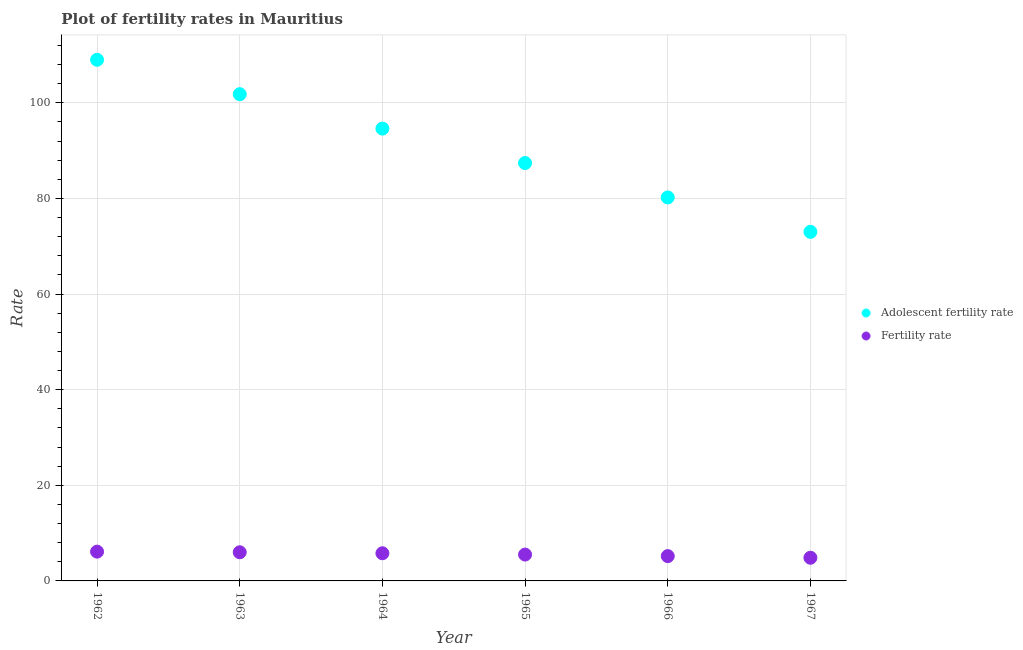How many different coloured dotlines are there?
Give a very brief answer. 2. Is the number of dotlines equal to the number of legend labels?
Keep it short and to the point. Yes. What is the fertility rate in 1964?
Your answer should be very brief. 5.79. Across all years, what is the maximum fertility rate?
Make the answer very short. 6.12. Across all years, what is the minimum adolescent fertility rate?
Keep it short and to the point. 73. In which year was the fertility rate minimum?
Offer a very short reply. 1967. What is the total adolescent fertility rate in the graph?
Give a very brief answer. 545.99. What is the difference between the adolescent fertility rate in 1964 and that in 1966?
Your response must be concise. 14.4. What is the difference between the adolescent fertility rate in 1966 and the fertility rate in 1965?
Your answer should be compact. 74.69. What is the average adolescent fertility rate per year?
Provide a short and direct response. 91. In the year 1966, what is the difference between the fertility rate and adolescent fertility rate?
Make the answer very short. -75.01. What is the ratio of the fertility rate in 1965 to that in 1967?
Provide a succinct answer. 1.14. Is the difference between the adolescent fertility rate in 1966 and 1967 greater than the difference between the fertility rate in 1966 and 1967?
Make the answer very short. Yes. What is the difference between the highest and the second highest fertility rate?
Give a very brief answer. 0.13. What is the difference between the highest and the lowest fertility rate?
Make the answer very short. 1.28. Is the sum of the adolescent fertility rate in 1962 and 1963 greater than the maximum fertility rate across all years?
Offer a very short reply. Yes. How many dotlines are there?
Keep it short and to the point. 2. What is the difference between two consecutive major ticks on the Y-axis?
Ensure brevity in your answer.  20. How many legend labels are there?
Offer a very short reply. 2. What is the title of the graph?
Make the answer very short. Plot of fertility rates in Mauritius. Does "Fraud firms" appear as one of the legend labels in the graph?
Offer a terse response. No. What is the label or title of the X-axis?
Keep it short and to the point. Year. What is the label or title of the Y-axis?
Provide a succinct answer. Rate. What is the Rate of Adolescent fertility rate in 1962?
Your answer should be very brief. 108.99. What is the Rate of Fertility rate in 1962?
Ensure brevity in your answer.  6.12. What is the Rate of Adolescent fertility rate in 1963?
Ensure brevity in your answer.  101.8. What is the Rate of Fertility rate in 1963?
Your answer should be very brief. 5.99. What is the Rate of Adolescent fertility rate in 1964?
Provide a succinct answer. 94.6. What is the Rate in Fertility rate in 1964?
Your answer should be very brief. 5.79. What is the Rate of Adolescent fertility rate in 1965?
Your response must be concise. 87.4. What is the Rate in Fertility rate in 1965?
Your answer should be compact. 5.51. What is the Rate in Adolescent fertility rate in 1966?
Give a very brief answer. 80.2. What is the Rate of Fertility rate in 1966?
Ensure brevity in your answer.  5.19. What is the Rate of Adolescent fertility rate in 1967?
Your response must be concise. 73. What is the Rate in Fertility rate in 1967?
Make the answer very short. 4.85. Across all years, what is the maximum Rate of Adolescent fertility rate?
Your answer should be very brief. 108.99. Across all years, what is the maximum Rate in Fertility rate?
Offer a terse response. 6.12. Across all years, what is the minimum Rate of Adolescent fertility rate?
Make the answer very short. 73. Across all years, what is the minimum Rate of Fertility rate?
Your answer should be compact. 4.85. What is the total Rate of Adolescent fertility rate in the graph?
Ensure brevity in your answer.  545.99. What is the total Rate in Fertility rate in the graph?
Your response must be concise. 33.45. What is the difference between the Rate of Adolescent fertility rate in 1962 and that in 1963?
Offer a terse response. 7.2. What is the difference between the Rate of Fertility rate in 1962 and that in 1963?
Provide a short and direct response. 0.13. What is the difference between the Rate in Adolescent fertility rate in 1962 and that in 1964?
Provide a succinct answer. 14.4. What is the difference between the Rate in Fertility rate in 1962 and that in 1964?
Provide a short and direct response. 0.34. What is the difference between the Rate of Adolescent fertility rate in 1962 and that in 1965?
Provide a succinct answer. 21.59. What is the difference between the Rate of Fertility rate in 1962 and that in 1965?
Keep it short and to the point. 0.61. What is the difference between the Rate in Adolescent fertility rate in 1962 and that in 1966?
Your answer should be very brief. 28.79. What is the difference between the Rate in Fertility rate in 1962 and that in 1966?
Your answer should be compact. 0.94. What is the difference between the Rate of Adolescent fertility rate in 1962 and that in 1967?
Your answer should be compact. 35.99. What is the difference between the Rate of Fertility rate in 1962 and that in 1967?
Make the answer very short. 1.28. What is the difference between the Rate of Adolescent fertility rate in 1963 and that in 1964?
Keep it short and to the point. 7.2. What is the difference between the Rate in Fertility rate in 1963 and that in 1964?
Make the answer very short. 0.21. What is the difference between the Rate of Adolescent fertility rate in 1963 and that in 1965?
Your response must be concise. 14.4. What is the difference between the Rate of Fertility rate in 1963 and that in 1965?
Make the answer very short. 0.48. What is the difference between the Rate in Adolescent fertility rate in 1963 and that in 1966?
Provide a short and direct response. 21.59. What is the difference between the Rate in Fertility rate in 1963 and that in 1966?
Your answer should be compact. 0.81. What is the difference between the Rate in Adolescent fertility rate in 1963 and that in 1967?
Your answer should be very brief. 28.79. What is the difference between the Rate of Fertility rate in 1963 and that in 1967?
Give a very brief answer. 1.15. What is the difference between the Rate in Adolescent fertility rate in 1964 and that in 1965?
Provide a succinct answer. 7.2. What is the difference between the Rate in Fertility rate in 1964 and that in 1965?
Provide a short and direct response. 0.28. What is the difference between the Rate in Adolescent fertility rate in 1964 and that in 1966?
Make the answer very short. 14.4. What is the difference between the Rate in Fertility rate in 1964 and that in 1966?
Your response must be concise. 0.6. What is the difference between the Rate of Adolescent fertility rate in 1964 and that in 1967?
Your answer should be compact. 21.59. What is the difference between the Rate of Fertility rate in 1964 and that in 1967?
Offer a terse response. 0.94. What is the difference between the Rate of Adolescent fertility rate in 1965 and that in 1966?
Provide a succinct answer. 7.2. What is the difference between the Rate of Fertility rate in 1965 and that in 1966?
Provide a short and direct response. 0.32. What is the difference between the Rate of Adolescent fertility rate in 1965 and that in 1967?
Keep it short and to the point. 14.4. What is the difference between the Rate in Fertility rate in 1965 and that in 1967?
Your response must be concise. 0.66. What is the difference between the Rate of Adolescent fertility rate in 1966 and that in 1967?
Offer a very short reply. 7.2. What is the difference between the Rate in Fertility rate in 1966 and that in 1967?
Keep it short and to the point. 0.34. What is the difference between the Rate in Adolescent fertility rate in 1962 and the Rate in Fertility rate in 1963?
Give a very brief answer. 103. What is the difference between the Rate of Adolescent fertility rate in 1962 and the Rate of Fertility rate in 1964?
Provide a short and direct response. 103.21. What is the difference between the Rate of Adolescent fertility rate in 1962 and the Rate of Fertility rate in 1965?
Your response must be concise. 103.48. What is the difference between the Rate of Adolescent fertility rate in 1962 and the Rate of Fertility rate in 1966?
Your answer should be very brief. 103.81. What is the difference between the Rate in Adolescent fertility rate in 1962 and the Rate in Fertility rate in 1967?
Give a very brief answer. 104.15. What is the difference between the Rate of Adolescent fertility rate in 1963 and the Rate of Fertility rate in 1964?
Offer a very short reply. 96.01. What is the difference between the Rate in Adolescent fertility rate in 1963 and the Rate in Fertility rate in 1965?
Provide a short and direct response. 96.29. What is the difference between the Rate of Adolescent fertility rate in 1963 and the Rate of Fertility rate in 1966?
Ensure brevity in your answer.  96.61. What is the difference between the Rate in Adolescent fertility rate in 1963 and the Rate in Fertility rate in 1967?
Your answer should be very brief. 96.95. What is the difference between the Rate in Adolescent fertility rate in 1964 and the Rate in Fertility rate in 1965?
Your response must be concise. 89.09. What is the difference between the Rate in Adolescent fertility rate in 1964 and the Rate in Fertility rate in 1966?
Give a very brief answer. 89.41. What is the difference between the Rate in Adolescent fertility rate in 1964 and the Rate in Fertility rate in 1967?
Your answer should be compact. 89.75. What is the difference between the Rate of Adolescent fertility rate in 1965 and the Rate of Fertility rate in 1966?
Give a very brief answer. 82.21. What is the difference between the Rate of Adolescent fertility rate in 1965 and the Rate of Fertility rate in 1967?
Provide a succinct answer. 82.55. What is the difference between the Rate in Adolescent fertility rate in 1966 and the Rate in Fertility rate in 1967?
Make the answer very short. 75.35. What is the average Rate of Adolescent fertility rate per year?
Your response must be concise. 91. What is the average Rate in Fertility rate per year?
Provide a succinct answer. 5.57. In the year 1962, what is the difference between the Rate of Adolescent fertility rate and Rate of Fertility rate?
Your answer should be very brief. 102.87. In the year 1963, what is the difference between the Rate in Adolescent fertility rate and Rate in Fertility rate?
Offer a very short reply. 95.8. In the year 1964, what is the difference between the Rate of Adolescent fertility rate and Rate of Fertility rate?
Make the answer very short. 88.81. In the year 1965, what is the difference between the Rate in Adolescent fertility rate and Rate in Fertility rate?
Ensure brevity in your answer.  81.89. In the year 1966, what is the difference between the Rate in Adolescent fertility rate and Rate in Fertility rate?
Provide a short and direct response. 75.01. In the year 1967, what is the difference between the Rate of Adolescent fertility rate and Rate of Fertility rate?
Provide a short and direct response. 68.16. What is the ratio of the Rate in Adolescent fertility rate in 1962 to that in 1963?
Make the answer very short. 1.07. What is the ratio of the Rate of Fertility rate in 1962 to that in 1963?
Provide a succinct answer. 1.02. What is the ratio of the Rate of Adolescent fertility rate in 1962 to that in 1964?
Offer a very short reply. 1.15. What is the ratio of the Rate of Fertility rate in 1962 to that in 1964?
Ensure brevity in your answer.  1.06. What is the ratio of the Rate of Adolescent fertility rate in 1962 to that in 1965?
Offer a very short reply. 1.25. What is the ratio of the Rate of Fertility rate in 1962 to that in 1965?
Make the answer very short. 1.11. What is the ratio of the Rate of Adolescent fertility rate in 1962 to that in 1966?
Give a very brief answer. 1.36. What is the ratio of the Rate in Fertility rate in 1962 to that in 1966?
Provide a succinct answer. 1.18. What is the ratio of the Rate of Adolescent fertility rate in 1962 to that in 1967?
Offer a terse response. 1.49. What is the ratio of the Rate of Fertility rate in 1962 to that in 1967?
Your answer should be very brief. 1.26. What is the ratio of the Rate in Adolescent fertility rate in 1963 to that in 1964?
Offer a terse response. 1.08. What is the ratio of the Rate in Fertility rate in 1963 to that in 1964?
Provide a short and direct response. 1.04. What is the ratio of the Rate of Adolescent fertility rate in 1963 to that in 1965?
Offer a terse response. 1.16. What is the ratio of the Rate in Fertility rate in 1963 to that in 1965?
Provide a short and direct response. 1.09. What is the ratio of the Rate in Adolescent fertility rate in 1963 to that in 1966?
Give a very brief answer. 1.27. What is the ratio of the Rate in Fertility rate in 1963 to that in 1966?
Provide a short and direct response. 1.16. What is the ratio of the Rate in Adolescent fertility rate in 1963 to that in 1967?
Make the answer very short. 1.39. What is the ratio of the Rate in Fertility rate in 1963 to that in 1967?
Offer a very short reply. 1.24. What is the ratio of the Rate of Adolescent fertility rate in 1964 to that in 1965?
Make the answer very short. 1.08. What is the ratio of the Rate of Fertility rate in 1964 to that in 1965?
Offer a terse response. 1.05. What is the ratio of the Rate in Adolescent fertility rate in 1964 to that in 1966?
Provide a succinct answer. 1.18. What is the ratio of the Rate in Fertility rate in 1964 to that in 1966?
Your response must be concise. 1.12. What is the ratio of the Rate of Adolescent fertility rate in 1964 to that in 1967?
Keep it short and to the point. 1.3. What is the ratio of the Rate of Fertility rate in 1964 to that in 1967?
Give a very brief answer. 1.19. What is the ratio of the Rate in Adolescent fertility rate in 1965 to that in 1966?
Your answer should be compact. 1.09. What is the ratio of the Rate in Fertility rate in 1965 to that in 1966?
Offer a very short reply. 1.06. What is the ratio of the Rate in Adolescent fertility rate in 1965 to that in 1967?
Offer a terse response. 1.2. What is the ratio of the Rate of Fertility rate in 1965 to that in 1967?
Provide a short and direct response. 1.14. What is the ratio of the Rate of Adolescent fertility rate in 1966 to that in 1967?
Offer a very short reply. 1.1. What is the ratio of the Rate of Fertility rate in 1966 to that in 1967?
Provide a short and direct response. 1.07. What is the difference between the highest and the second highest Rate in Adolescent fertility rate?
Provide a succinct answer. 7.2. What is the difference between the highest and the second highest Rate of Fertility rate?
Offer a very short reply. 0.13. What is the difference between the highest and the lowest Rate of Adolescent fertility rate?
Offer a very short reply. 35.99. What is the difference between the highest and the lowest Rate in Fertility rate?
Offer a terse response. 1.28. 